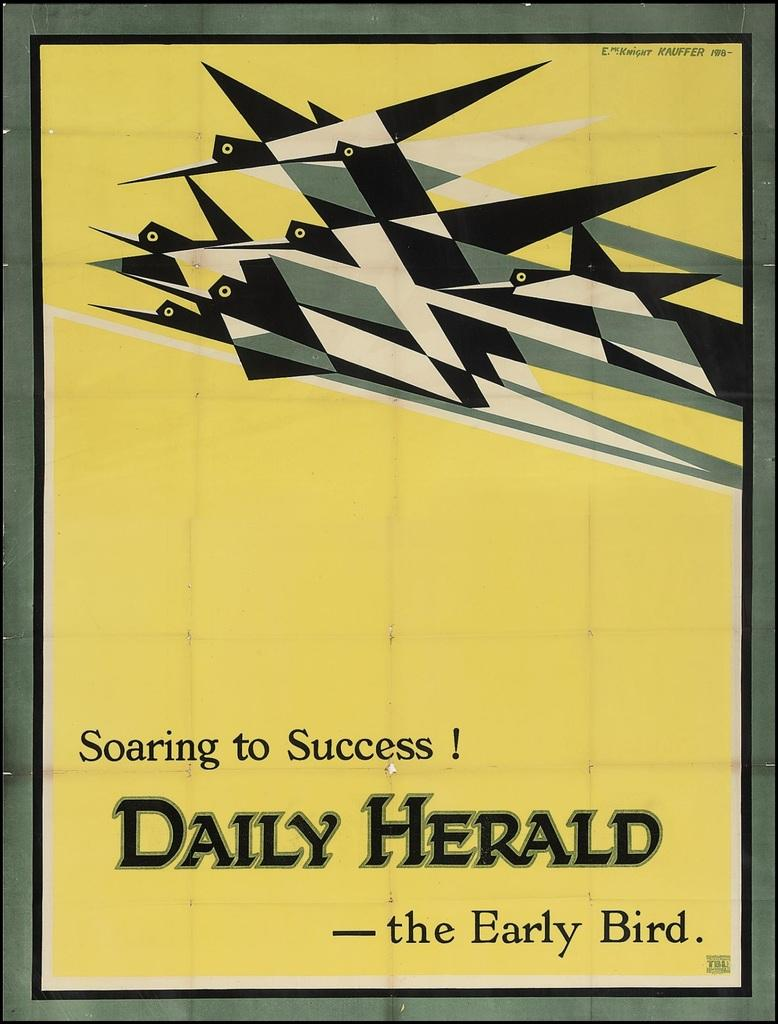<image>
Give a short and clear explanation of the subsequent image. An advertisement about success printed in Daily Herald. 